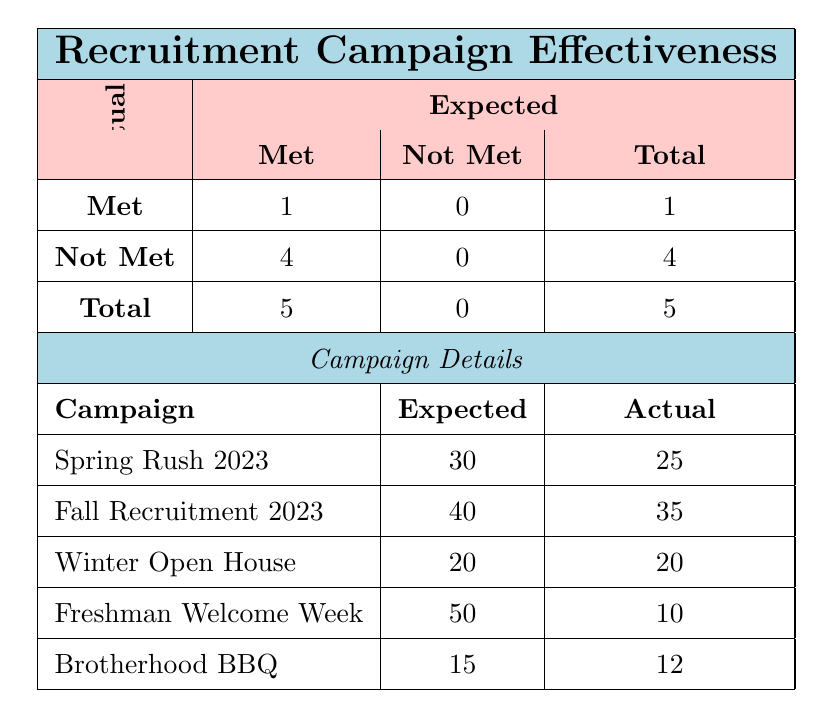What was the actual number of new members from the 'Winter Open House' campaign? The table shows that for the 'Winter Open House' campaign, the actual number of new members is specified directly under the 'Actual' column. The value listed is 20.
Answer: 20 How many recruitment campaigns met their expected new members? According to the table, there is only one campaign that met its expected new members, which can be found in the 'Met' section under 'Actual' and 'Expected'. The value is 1, corresponding to the 'Winter Open House' campaign.
Answer: 1 What is the total number of campaigns listed? To find the total number of campaigns, we count the rows under the 'Campaign Details' section. There are five campaigns listed: 'Spring Rush 2023', 'Fall Recruitment 2023', 'Winter Open House', 'Freshman Welcome Week', and 'Brotherhood BBQ'. Therefore, the total is 5.
Answer: 5 What is the difference between the expected new members and actual new members for the 'Freshman Welcome Week' campaign? For the 'Freshman Welcome Week', the expected new members are 50 and the actual new members are 10. The difference is calculated by subtracting the actual value from the expected value: 50 - 10 = 40.
Answer: 40 Did the 'Brotherhood BBQ' campaign meet its expected new members? The table specifies that the expected new members for the 'Brotherhood BBQ' campaign is 15, while the actual new members is 12. Since the actual is less than the expected, the conclusion is that it did not meet its expected new members.
Answer: No What percentage of expected new members was achieved for the 'Fall Recruitment 2023' campaign? For the 'Fall Recruitment 2023' campaign, the expected new members were 40, and the actual was 35. To calculate the percentage achieved, we use the formula (Actual / Expected) * 100 = (35 / 40) * 100 = 87.5%. This shows the proportion of expected new members that were actualized.
Answer: 87.5% Which campaign had the highest shortfall in actual members compared to their expected numbers? We can determine the shortfall by calculating the difference between expected and actual members for each campaign. The highest shortfall is for the 'Freshman Welcome Week', where 50 expected minus 10 actual gives a shortfall of 40. This is greater than the other campaigns.
Answer: 'Freshman Welcome Week' Was there a campaign that exactly met its expected new members? The 'Winter Open House' campaign shows both the expected and actual new members as 20. Since these two values are equal, it can be concluded that this campaign did exactly meet its expected new members.
Answer: Yes 